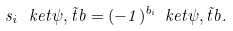Convert formula to latex. <formula><loc_0><loc_0><loc_500><loc_500>s _ { i } \, \ k e t { \psi , \vec { t } b } = ( - 1 ) ^ { b _ { i } } \ k e t { \psi , \vec { t } b } .</formula> 